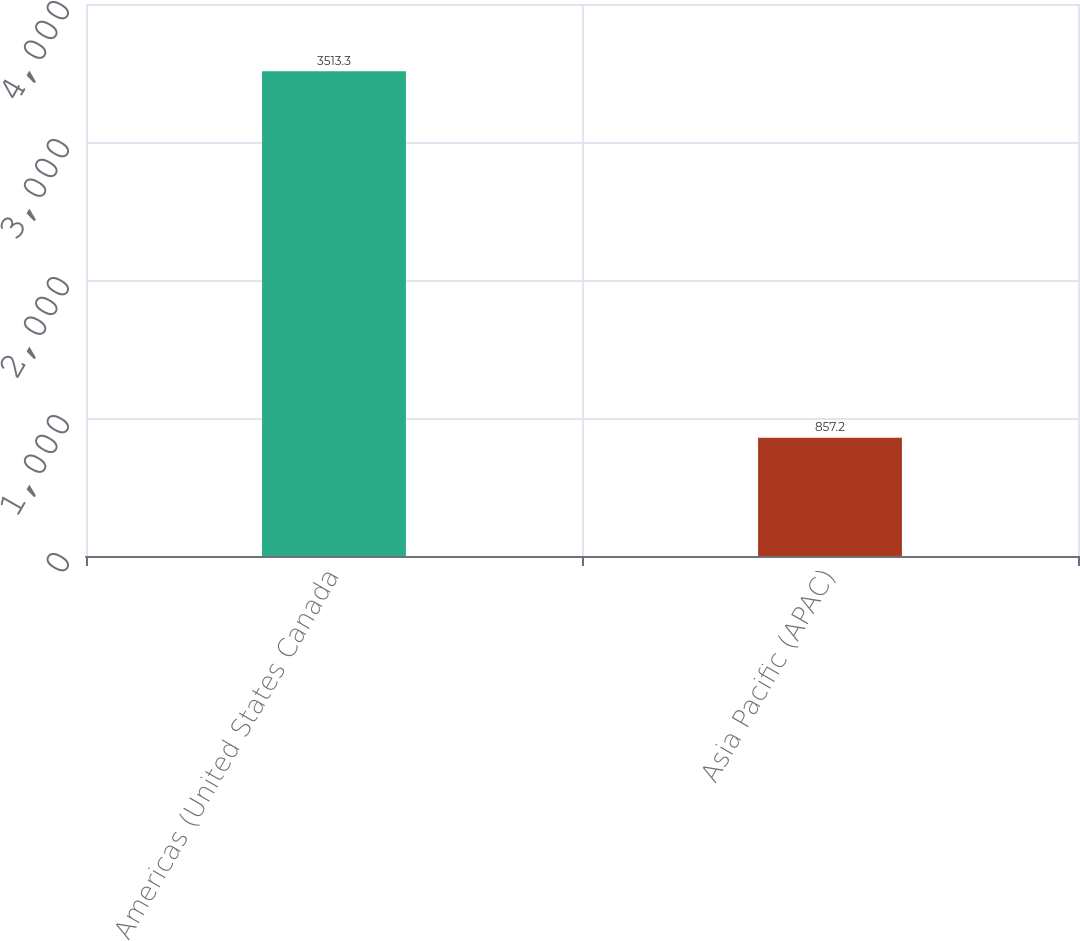Convert chart to OTSL. <chart><loc_0><loc_0><loc_500><loc_500><bar_chart><fcel>Americas (United States Canada<fcel>Asia Pacific (APAC)<nl><fcel>3513.3<fcel>857.2<nl></chart> 